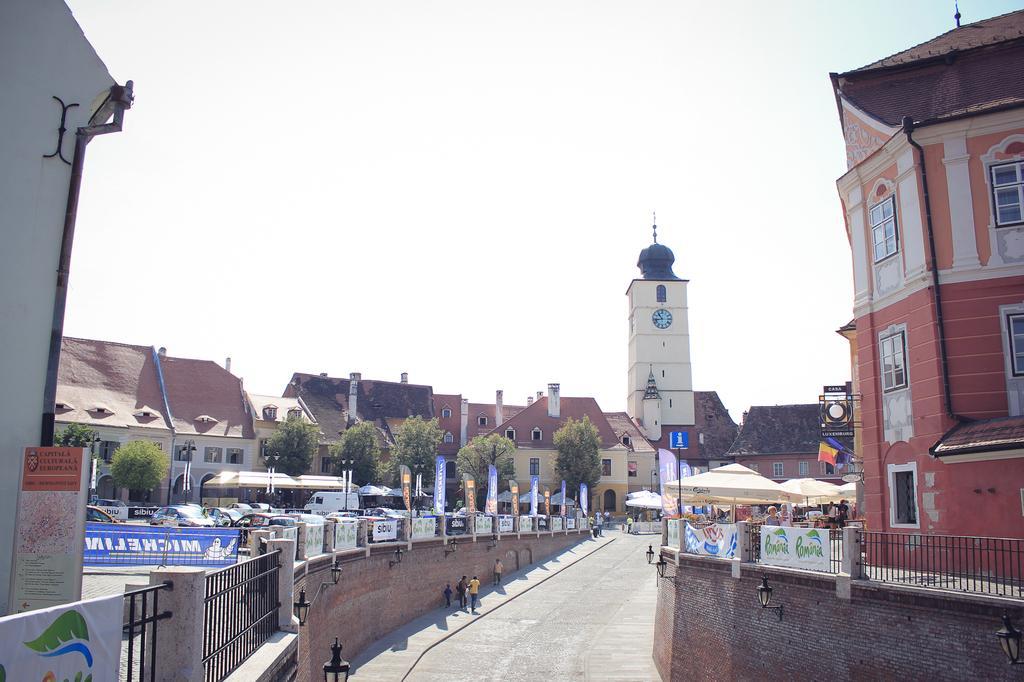How would you summarize this image in a sentence or two? This is an outside view. At the bottom of the image I can see the road and few people are walking on the footpath. On both sides of the road I can see the buildings. In the background there are some trees and a clock tower. At the top of the image I can see the sky. 